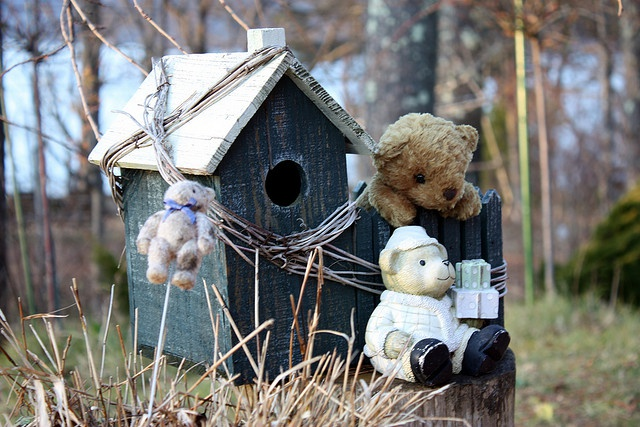Describe the objects in this image and their specific colors. I can see teddy bear in black, lightgray, darkgray, and lightblue tones, teddy bear in black, maroon, gray, and darkgray tones, and teddy bear in black, lightgray, darkgray, and gray tones in this image. 